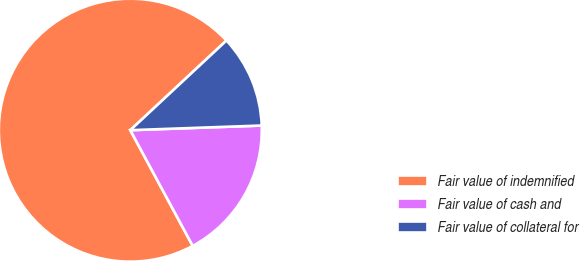<chart> <loc_0><loc_0><loc_500><loc_500><pie_chart><fcel>Fair value of indemnified<fcel>Fair value of cash and<fcel>Fair value of collateral for<nl><fcel>70.93%<fcel>17.69%<fcel>11.38%<nl></chart> 